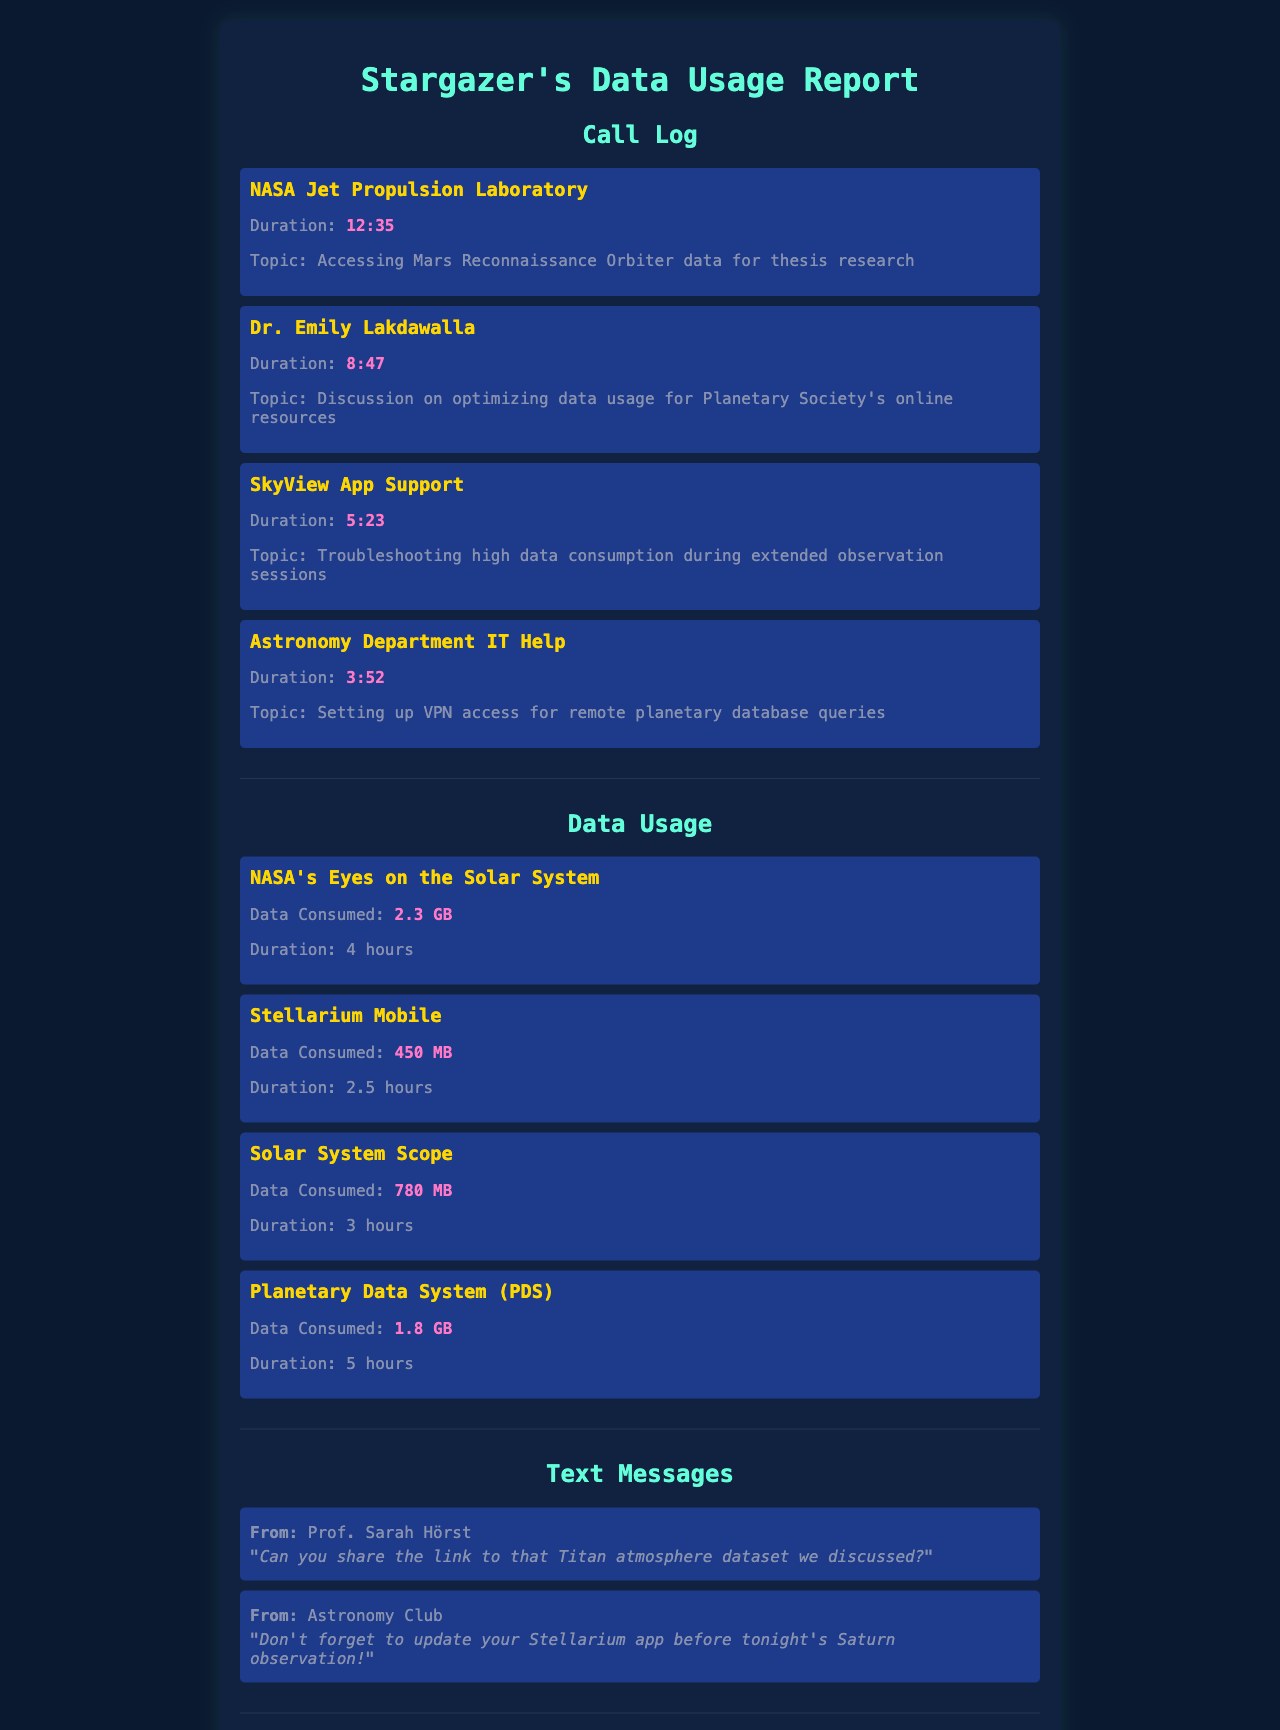What was the total call duration for the calls listed? The total call duration can be calculated by adding the duration of each call: 12:35 + 8:47 + 5:23 + 3:52 = 30:37.
Answer: 30:37 How much data was consumed by NASA's Eyes on the Solar System? The document specifies the data consumed by NASA's Eyes on the Solar System as 2.3 GB.
Answer: 2.3 GB Who did the caller have a discussion with regarding data usage optimization? The call log mentions a discussion on optimizing data usage with Dr. Emily Lakdawalla.
Answer: Dr. Emily Lakdawalla What is the total data consumption from all stargazing apps listed? The total data consumption is the sum of all stargazing apps: 2.3 GB + 450 MB + 780 MB + 1.8 GB. Converting everything to GB gives: (2.3 + 0.45 + 0.78 + 1.8) GB = 5.33 GB.
Answer: 5.33 GB Which app consumed the least amount of data? Among the listed apps, Stellarium Mobile consumed the least amount of data at 450 MB.
Answer: Stellarium Mobile 